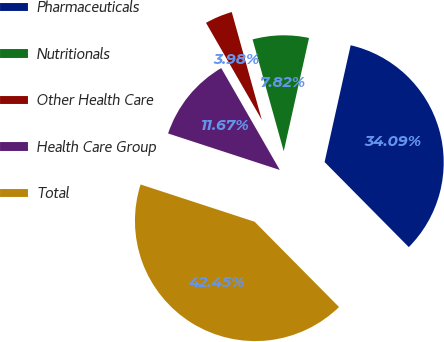Convert chart to OTSL. <chart><loc_0><loc_0><loc_500><loc_500><pie_chart><fcel>Pharmaceuticals<fcel>Nutritionals<fcel>Other Health Care<fcel>Health Care Group<fcel>Total<nl><fcel>34.09%<fcel>7.82%<fcel>3.98%<fcel>11.67%<fcel>42.45%<nl></chart> 